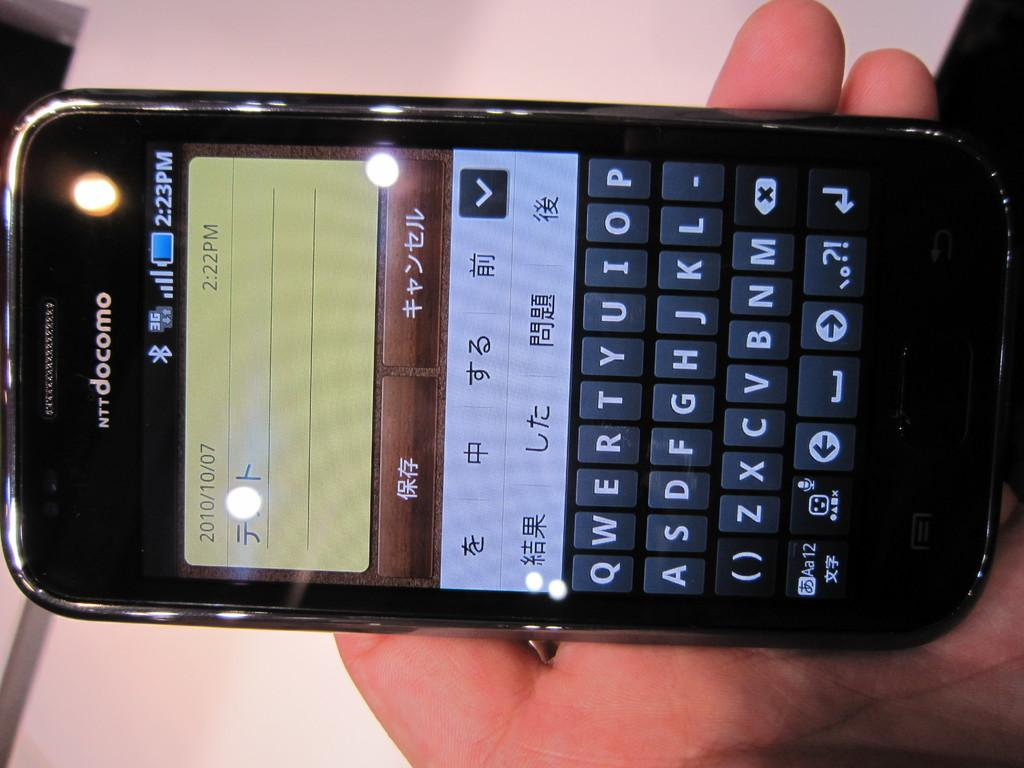What is the main subject of the image? There is a person in the image. What is the person holding in the image? The person is holding a cellphone. What type of brass instrument is the person playing in the image? There is no brass instrument present in the image; the person is holding a cellphone. 